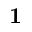Convert formula to latex. <formula><loc_0><loc_0><loc_500><loc_500>1</formula> 